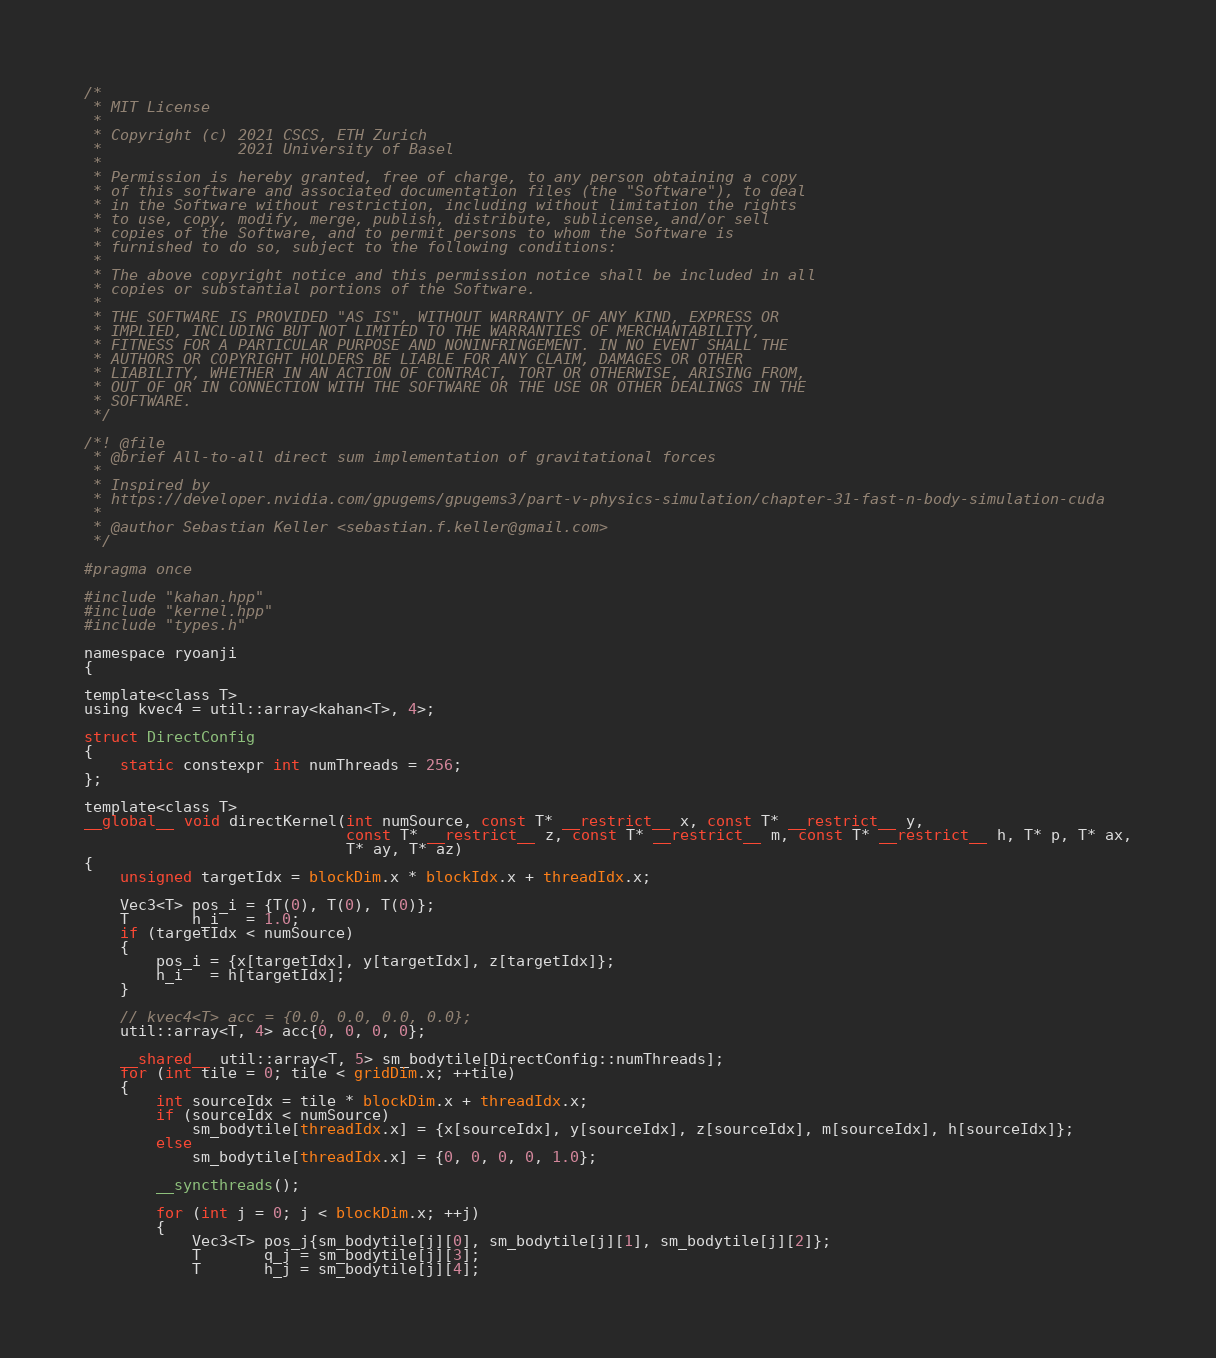<code> <loc_0><loc_0><loc_500><loc_500><_Cuda_>/*
 * MIT License
 *
 * Copyright (c) 2021 CSCS, ETH Zurich
 *               2021 University of Basel
 *
 * Permission is hereby granted, free of charge, to any person obtaining a copy
 * of this software and associated documentation files (the "Software"), to deal
 * in the Software without restriction, including without limitation the rights
 * to use, copy, modify, merge, publish, distribute, sublicense, and/or sell
 * copies of the Software, and to permit persons to whom the Software is
 * furnished to do so, subject to the following conditions:
 *
 * The above copyright notice and this permission notice shall be included in all
 * copies or substantial portions of the Software.
 *
 * THE SOFTWARE IS PROVIDED "AS IS", WITHOUT WARRANTY OF ANY KIND, EXPRESS OR
 * IMPLIED, INCLUDING BUT NOT LIMITED TO THE WARRANTIES OF MERCHANTABILITY,
 * FITNESS FOR A PARTICULAR PURPOSE AND NONINFRINGEMENT. IN NO EVENT SHALL THE
 * AUTHORS OR COPYRIGHT HOLDERS BE LIABLE FOR ANY CLAIM, DAMAGES OR OTHER
 * LIABILITY, WHETHER IN AN ACTION OF CONTRACT, TORT OR OTHERWISE, ARISING FROM,
 * OUT OF OR IN CONNECTION WITH THE SOFTWARE OR THE USE OR OTHER DEALINGS IN THE
 * SOFTWARE.
 */

/*! @file
 * @brief All-to-all direct sum implementation of gravitational forces
 *
 * Inspired by
 * https://developer.nvidia.com/gpugems/gpugems3/part-v-physics-simulation/chapter-31-fast-n-body-simulation-cuda
 *
 * @author Sebastian Keller <sebastian.f.keller@gmail.com>
 */

#pragma once

#include "kahan.hpp"
#include "kernel.hpp"
#include "types.h"

namespace ryoanji
{

template<class T>
using kvec4 = util::array<kahan<T>, 4>;

struct DirectConfig
{
    static constexpr int numThreads = 256;
};

template<class T>
__global__ void directKernel(int numSource, const T* __restrict__ x, const T* __restrict__ y,
                             const T* __restrict__ z, const T* __restrict__ m, const T* __restrict__ h, T* p, T* ax,
                             T* ay, T* az)
{
    unsigned targetIdx = blockDim.x * blockIdx.x + threadIdx.x;

    Vec3<T> pos_i = {T(0), T(0), T(0)};
    T       h_i   = 1.0;
    if (targetIdx < numSource)
    {
        pos_i = {x[targetIdx], y[targetIdx], z[targetIdx]};
        h_i   = h[targetIdx];
    }

    // kvec4<T> acc = {0.0, 0.0, 0.0, 0.0};
    util::array<T, 4> acc{0, 0, 0, 0};

    __shared__ util::array<T, 5> sm_bodytile[DirectConfig::numThreads];
    for (int tile = 0; tile < gridDim.x; ++tile)
    {
        int sourceIdx = tile * blockDim.x + threadIdx.x;
        if (sourceIdx < numSource)
            sm_bodytile[threadIdx.x] = {x[sourceIdx], y[sourceIdx], z[sourceIdx], m[sourceIdx], h[sourceIdx]};
        else
            sm_bodytile[threadIdx.x] = {0, 0, 0, 0, 1.0};

        __syncthreads();

        for (int j = 0; j < blockDim.x; ++j)
        {
            Vec3<T> pos_j{sm_bodytile[j][0], sm_bodytile[j][1], sm_bodytile[j][2]};
            T       q_j = sm_bodytile[j][3];
            T       h_j = sm_bodytile[j][4];
</code> 